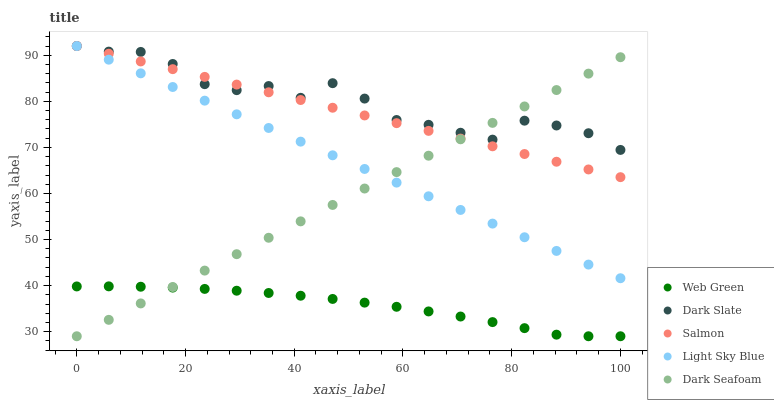Does Web Green have the minimum area under the curve?
Answer yes or no. Yes. Does Dark Slate have the maximum area under the curve?
Answer yes or no. Yes. Does Dark Seafoam have the minimum area under the curve?
Answer yes or no. No. Does Dark Seafoam have the maximum area under the curve?
Answer yes or no. No. Is Dark Seafoam the smoothest?
Answer yes or no. Yes. Is Dark Slate the roughest?
Answer yes or no. Yes. Is Light Sky Blue the smoothest?
Answer yes or no. No. Is Light Sky Blue the roughest?
Answer yes or no. No. Does Dark Seafoam have the lowest value?
Answer yes or no. Yes. Does Light Sky Blue have the lowest value?
Answer yes or no. No. Does Salmon have the highest value?
Answer yes or no. Yes. Does Dark Seafoam have the highest value?
Answer yes or no. No. Is Web Green less than Dark Slate?
Answer yes or no. Yes. Is Light Sky Blue greater than Web Green?
Answer yes or no. Yes. Does Dark Seafoam intersect Dark Slate?
Answer yes or no. Yes. Is Dark Seafoam less than Dark Slate?
Answer yes or no. No. Is Dark Seafoam greater than Dark Slate?
Answer yes or no. No. Does Web Green intersect Dark Slate?
Answer yes or no. No. 